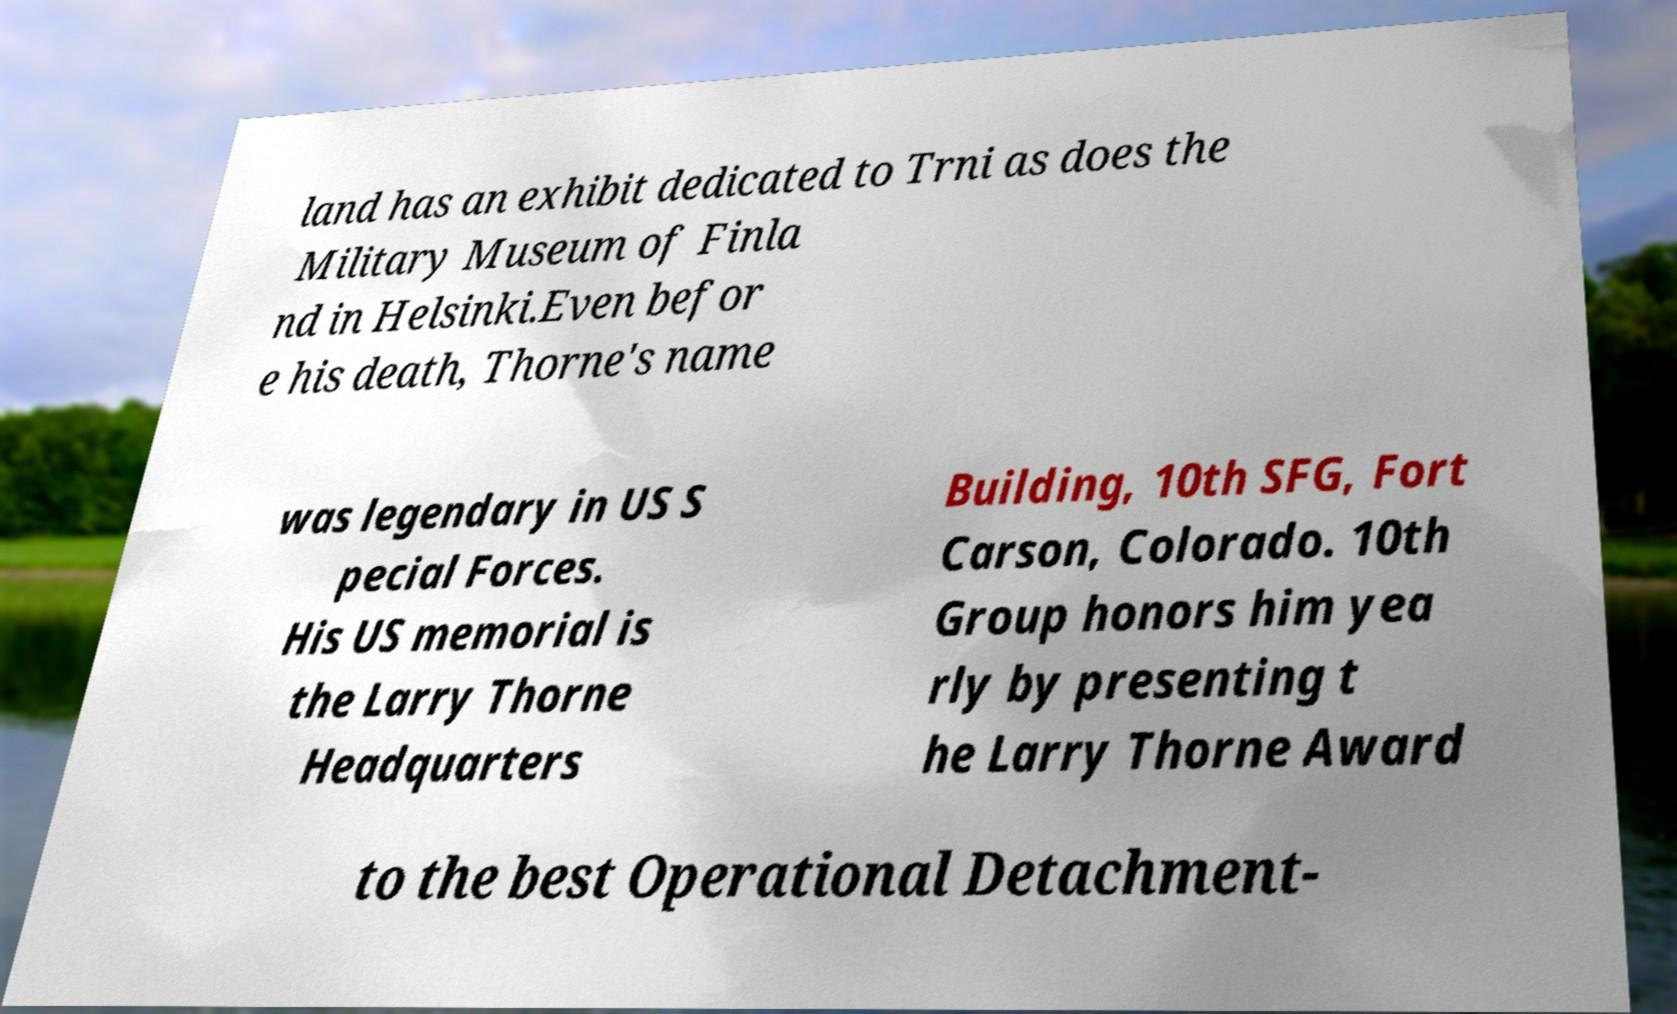I need the written content from this picture converted into text. Can you do that? land has an exhibit dedicated to Trni as does the Military Museum of Finla nd in Helsinki.Even befor e his death, Thorne's name was legendary in US S pecial Forces. His US memorial is the Larry Thorne Headquarters Building, 10th SFG, Fort Carson, Colorado. 10th Group honors him yea rly by presenting t he Larry Thorne Award to the best Operational Detachment- 